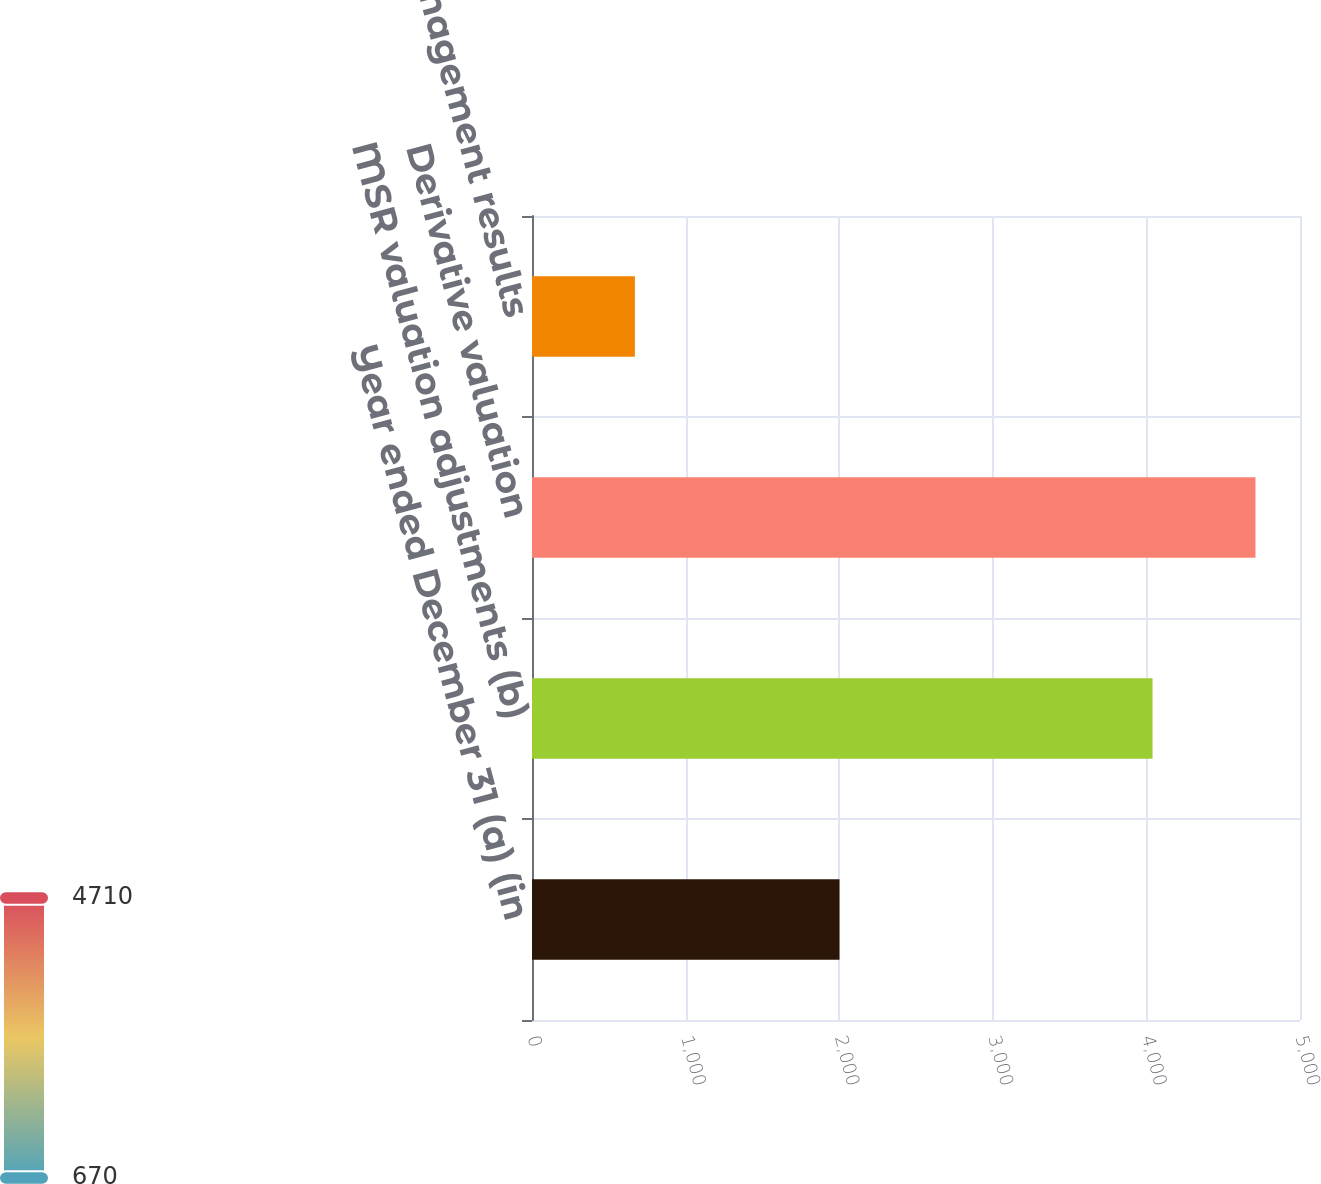Convert chart. <chart><loc_0><loc_0><loc_500><loc_500><bar_chart><fcel>Year ended December 31 (a) (in<fcel>MSR valuation adjustments (b)<fcel>Derivative valuation<fcel>MSR risk management results<nl><fcel>2002<fcel>4040<fcel>4710<fcel>670<nl></chart> 